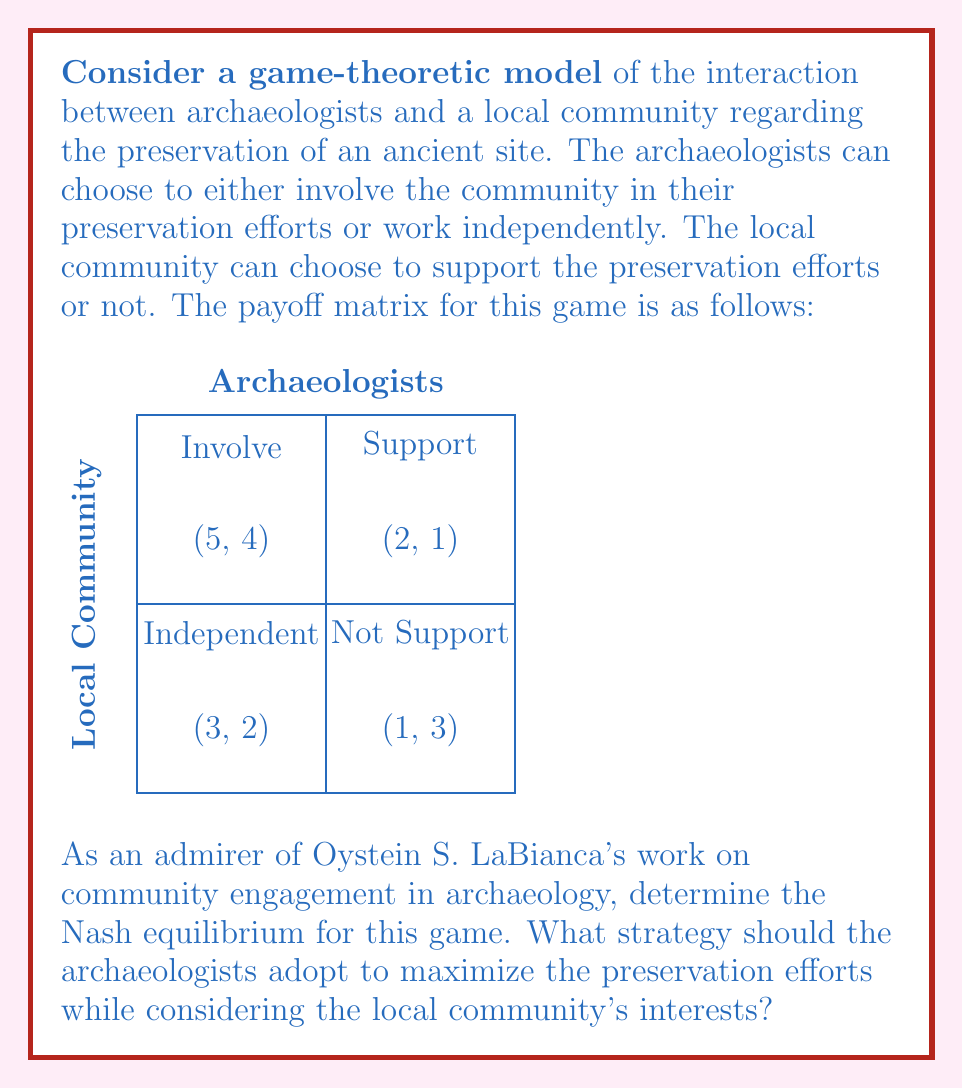Can you solve this math problem? To solve this game and find the Nash equilibrium, we need to analyze each player's best response to the other player's strategies. Let's approach this step-by-step:

1) First, let's consider the archaeologists' strategies:
   - If the community supports, archaeologists get 5 if they involve and 2 if they work independently.
   - If the community doesn't support, archaeologists get 3 if they involve and 1 if they work independently.
   In both cases, involving the community is the best strategy for archaeologists.

2) Now, let's consider the local community's strategies:
   - If archaeologists involve them, the community gets 4 if they support and 2 if they don't.
   - If archaeologists work independently, the community gets 1 if they support and 3 if they don't.

3) We can see that:
   - The community's best response to involvement is support (4 > 2).
   - The community's best response to independent work is not support (3 > 1).

4) Given that involving the community is always the best strategy for archaeologists, and the community's best response to involvement is support, we can identify the Nash equilibrium:

   $$(Involve, Support)$$

   This strategy pair is stable because neither player can unilaterally change their strategy to improve their payoff.

5) This result aligns with LaBianca's emphasis on community engagement in archaeology. By involving the local community, archaeologists can achieve the highest payoff (5) while also providing the highest payoff for the community (4), leading to the most effective preservation efforts.
Answer: (Involve, Support) 